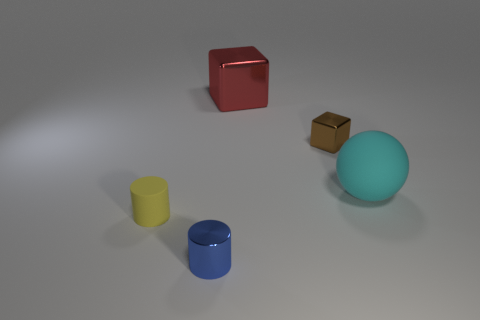Is there a large brown matte object that has the same shape as the tiny brown metallic object?
Provide a succinct answer. No. Is the shape of the matte thing left of the large rubber object the same as the matte thing right of the yellow object?
Offer a very short reply. No. Are there any yellow rubber cylinders of the same size as the brown metal block?
Your response must be concise. Yes. Are there an equal number of objects that are in front of the tiny matte object and red objects in front of the big cyan thing?
Provide a succinct answer. No. Is the small object that is behind the big cyan object made of the same material as the large object that is left of the sphere?
Offer a terse response. Yes. What material is the yellow cylinder?
Give a very brief answer. Rubber. How many other objects are there of the same color as the matte cylinder?
Make the answer very short. 0. Does the tiny block have the same color as the large rubber sphere?
Give a very brief answer. No. How many large blue objects are there?
Give a very brief answer. 0. There is a small cube that is behind the small object that is to the left of the small blue thing; what is its material?
Offer a very short reply. Metal. 